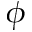<formula> <loc_0><loc_0><loc_500><loc_500>\phi</formula> 